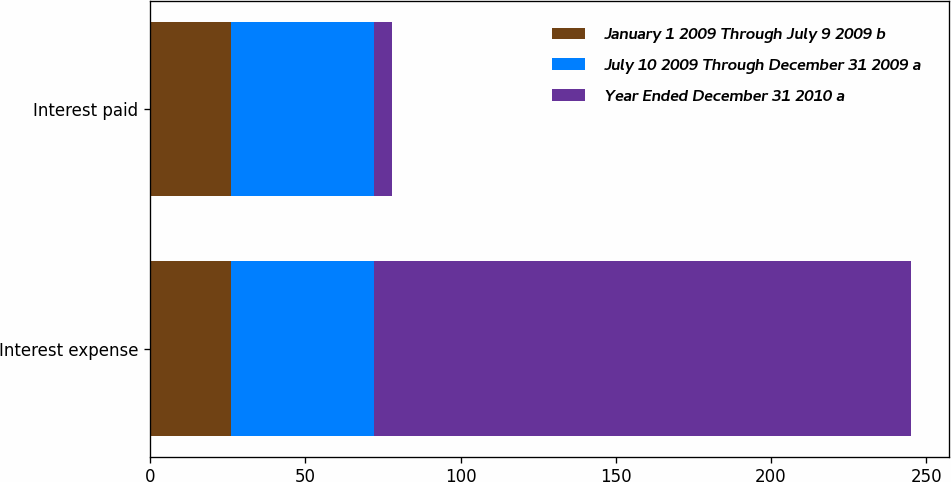<chart> <loc_0><loc_0><loc_500><loc_500><stacked_bar_chart><ecel><fcel>Interest expense<fcel>Interest paid<nl><fcel>January 1 2009 Through July 9 2009 b<fcel>26<fcel>26<nl><fcel>July 10 2009 Through December 31 2009 a<fcel>46<fcel>46<nl><fcel>Year Ended December 31 2010 a<fcel>173<fcel>6<nl></chart> 